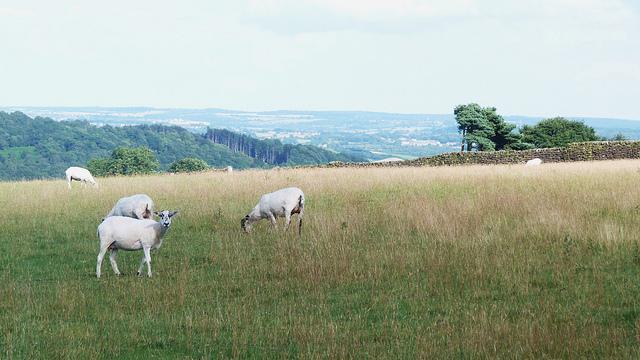How many sheepskin are grazing?
Give a very brief answer. 4. 